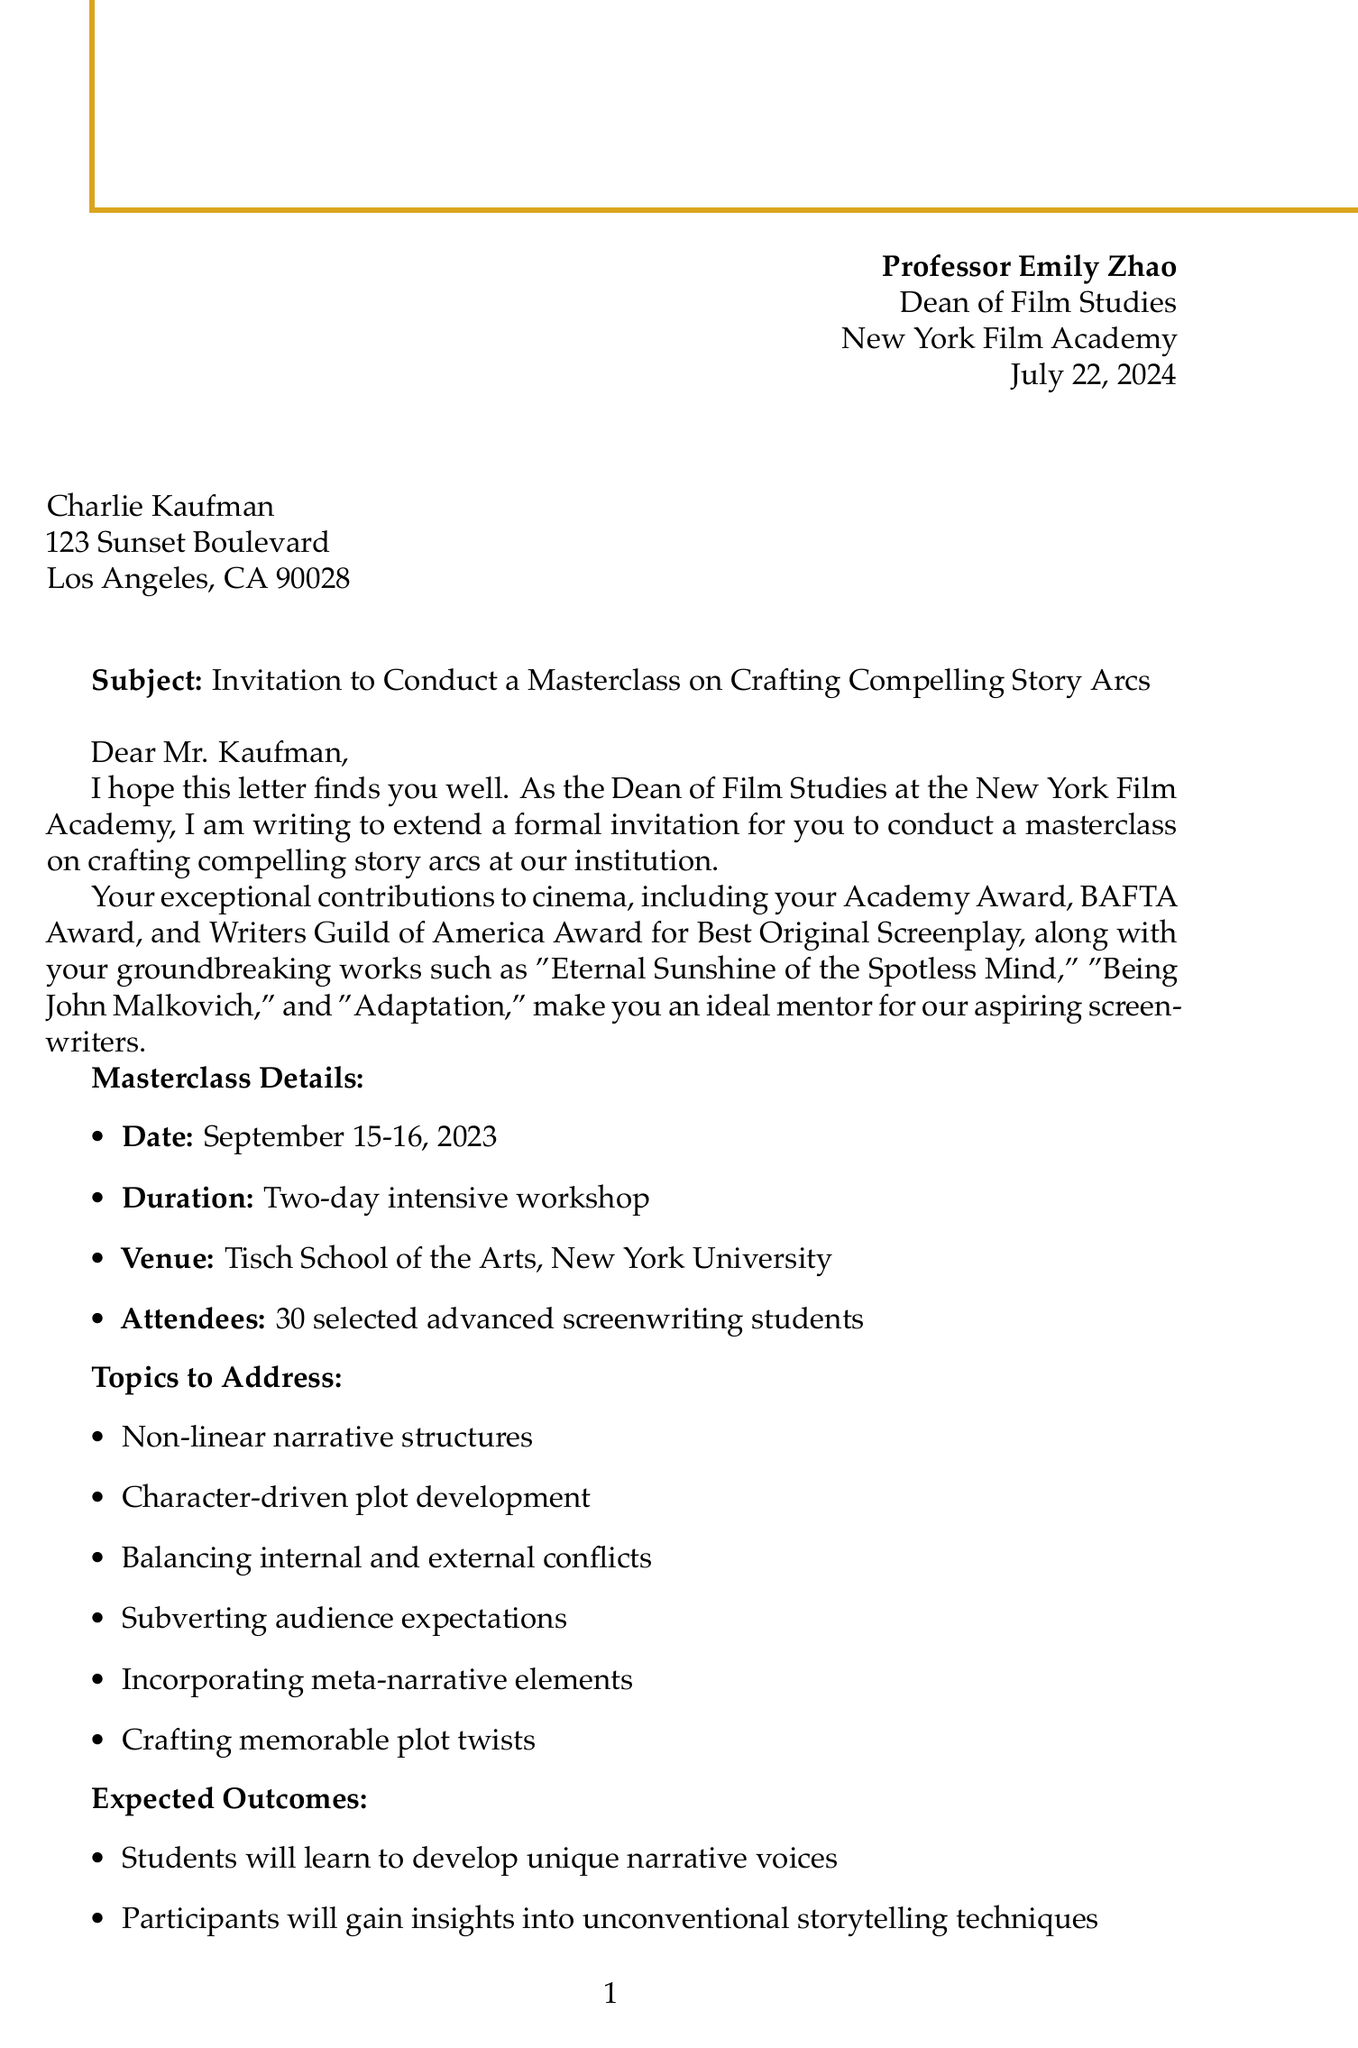What is the sender's name? The sender's name is stated at the beginning of the letter, identifying Professor Emily Zhao.
Answer: Professor Emily Zhao What are the notable works of Charlie Kaufman? Notable works are listed in the introduction of the letter, highlighting significant films he has written.
Answer: Eternal Sunshine of the Spotless Mind, Being John Malkovich, Adaptation When is the masterclass scheduled? The date of the masterclass is mentioned explicitly in the details provided in the document.
Answer: September 15-16, 2023 What is the compensation amount offered? The compensation section specifies the honorarium being offered to Charlie Kaufman.
Answer: $10,000 How many students will attend the masterclass? The letter states the number of selected advanced screenwriting students set to participate in the masterclass.
Answer: 30 What important film festival pass is included as a perk? The additional perks section of the letter mentions a VIP pass to a specific film festival.
Answer: Tribeca Film Festival What is one topic to be addressed in the masterclass? The letter lists several topics, and one can be selected from that list for the answer.
Answer: Non-linear narrative structures What is the role of Michael Chen mentioned in the letter? Michael Chen is referenced in the closing remarks, indicating his role in the coordination of the masterclass details.
Answer: Program coordinator Which institution is hosting the masterclass? The venue specified in the masterclass details indicates where this event will take place.
Answer: Tisch School of the Arts, New York University 